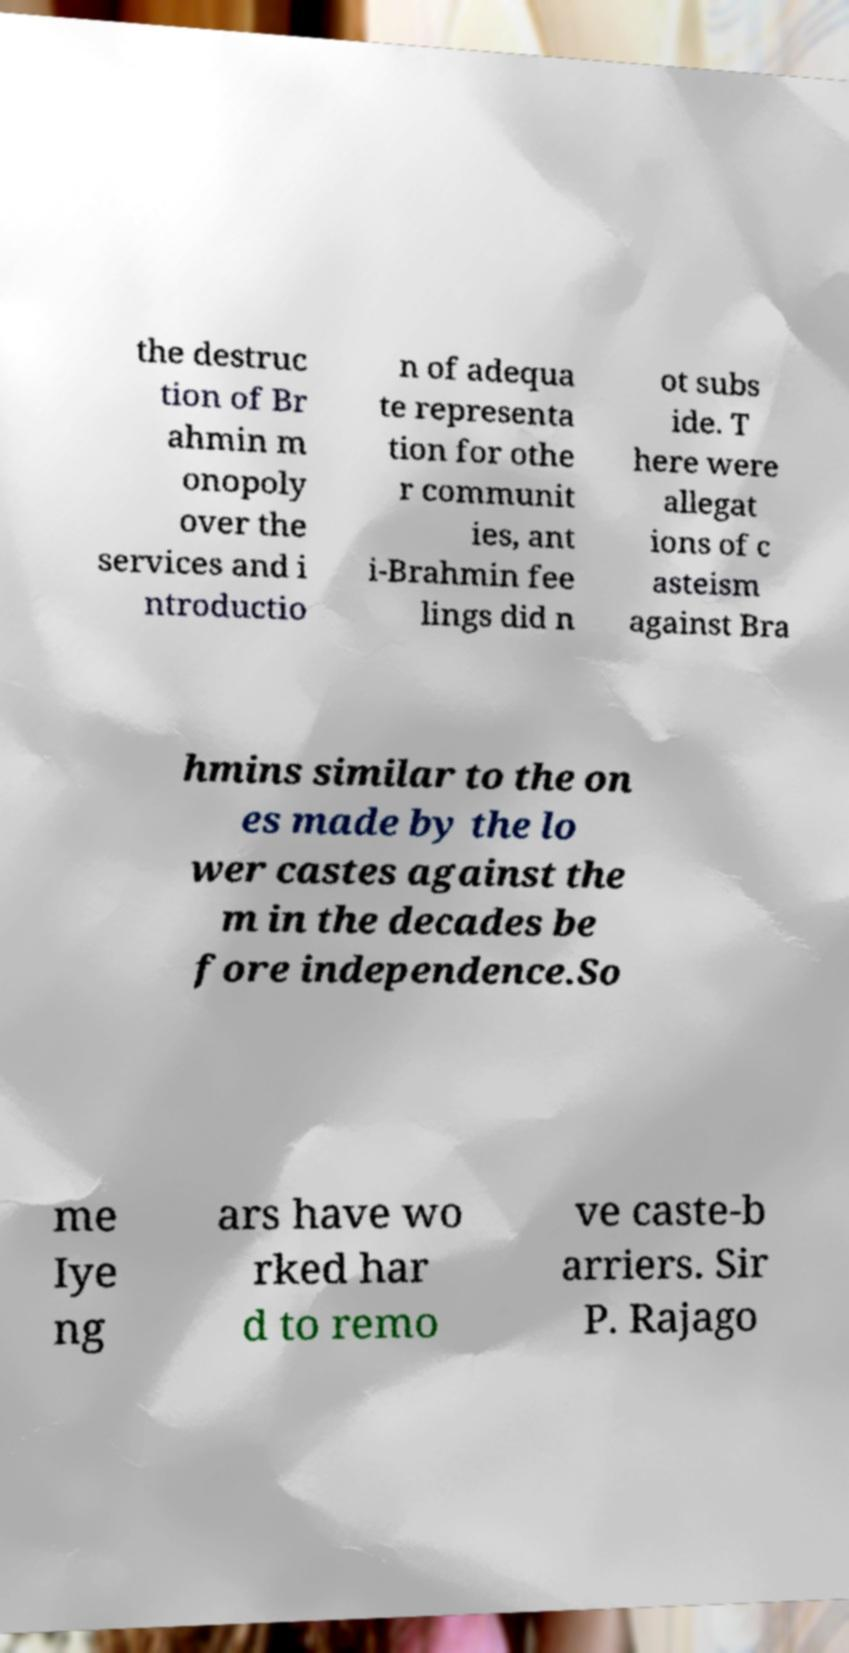Please read and relay the text visible in this image. What does it say? the destruc tion of Br ahmin m onopoly over the services and i ntroductio n of adequa te representa tion for othe r communit ies, ant i-Brahmin fee lings did n ot subs ide. T here were allegat ions of c asteism against Bra hmins similar to the on es made by the lo wer castes against the m in the decades be fore independence.So me Iye ng ars have wo rked har d to remo ve caste-b arriers. Sir P. Rajago 